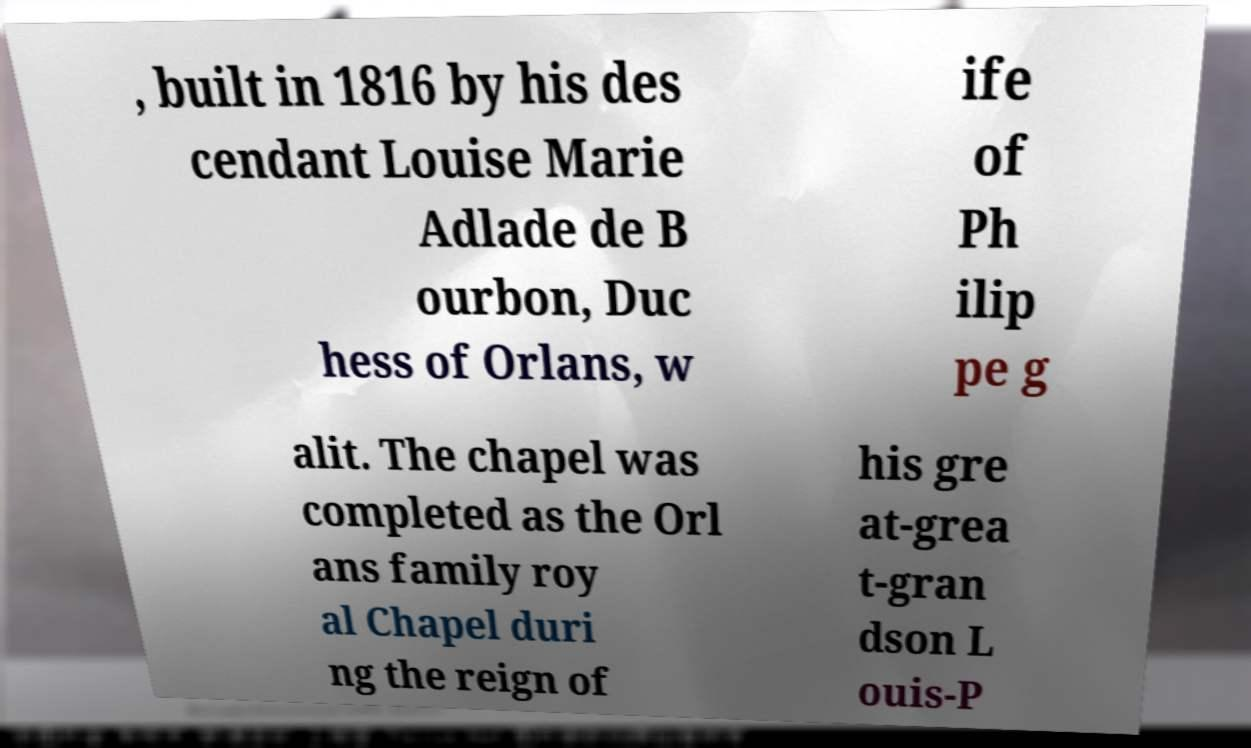I need the written content from this picture converted into text. Can you do that? , built in 1816 by his des cendant Louise Marie Adlade de B ourbon, Duc hess of Orlans, w ife of Ph ilip pe g alit. The chapel was completed as the Orl ans family roy al Chapel duri ng the reign of his gre at-grea t-gran dson L ouis-P 